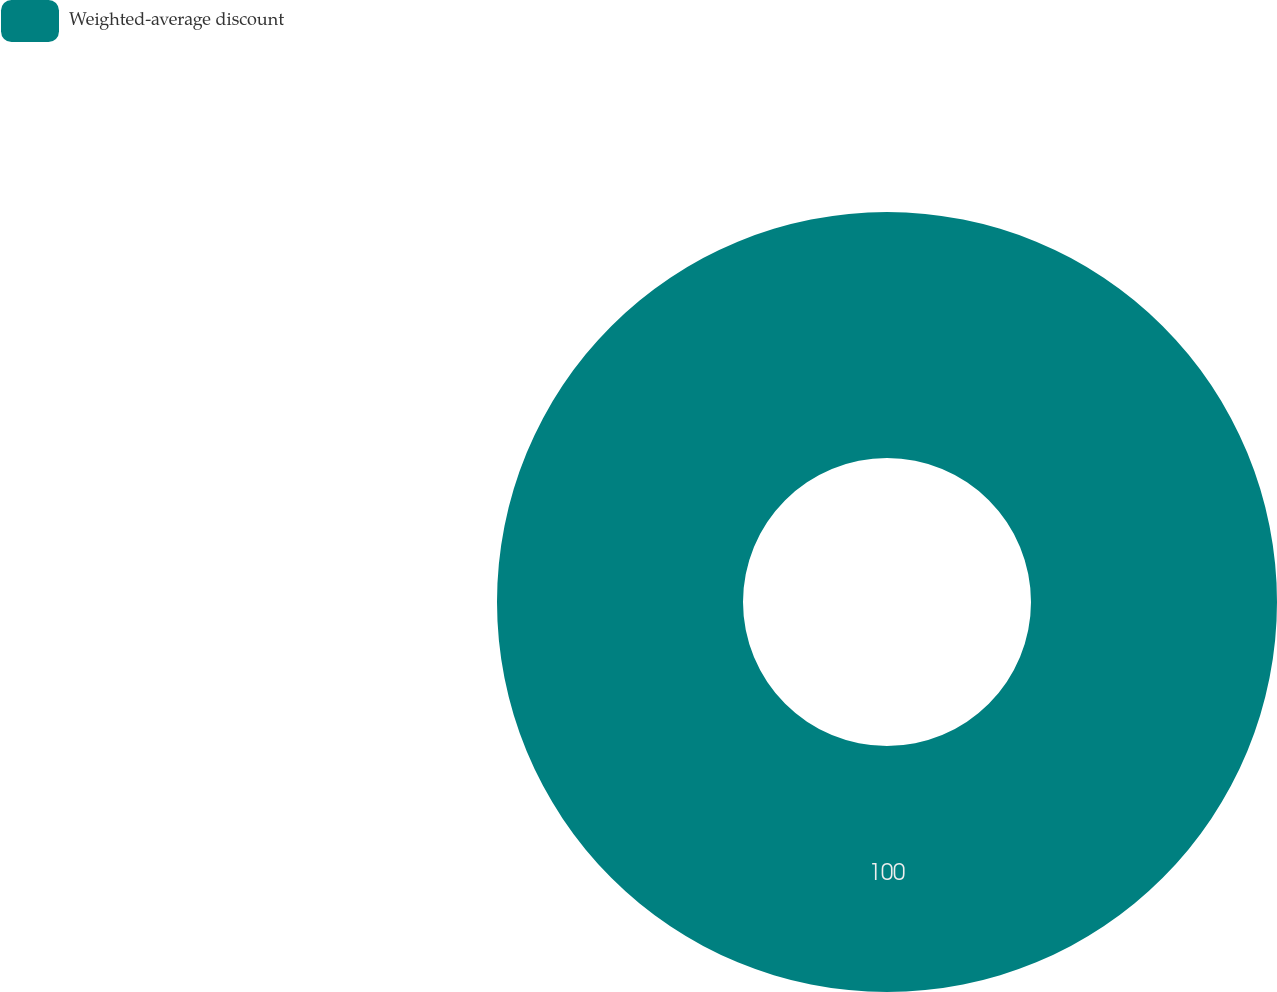Convert chart to OTSL. <chart><loc_0><loc_0><loc_500><loc_500><pie_chart><fcel>Weighted-average discount<nl><fcel>100.0%<nl></chart> 